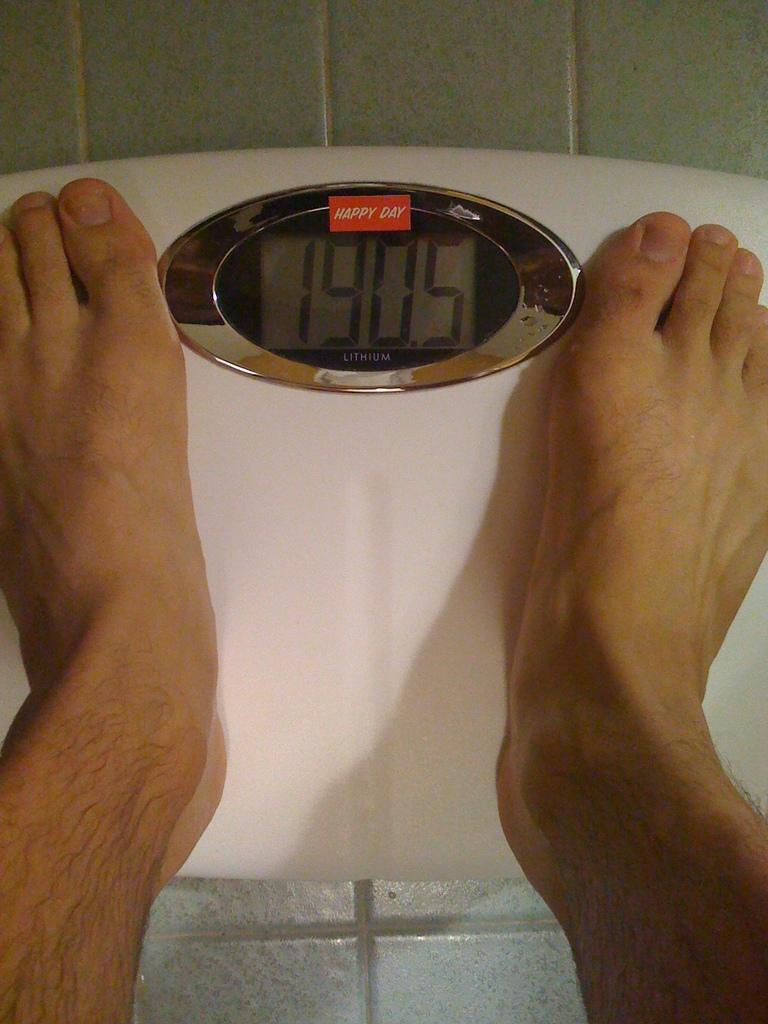<image>
Write a terse but informative summary of the picture. a Happy Day brand scale displaying a person's weight as 190.5 